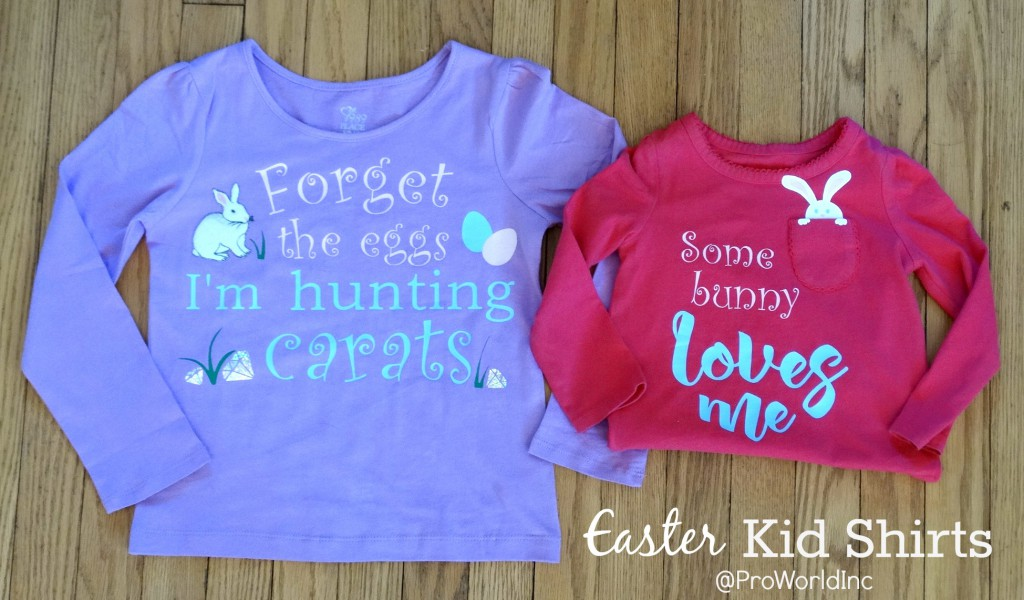Can you tell more about the design theme of these shirts? The shirts feature playful Easter-themed designs. The purple shirt uses a pun 'Forget the eggs I'm hunting carrots', incorporating both Easter eggs and the Easter bunny's motif in a unique way. The red shirt's phrase 'Some bunny loves me' coupled with the bunny graphic adds a charming and affectionate touch, making these shirts fun for the holiday. 